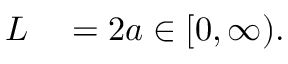<formula> <loc_0><loc_0><loc_500><loc_500>\begin{array} { r l } { L } & = 2 a \in [ 0 , \infty ) . } \end{array}</formula> 